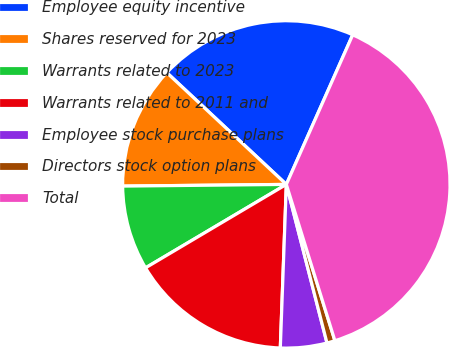Convert chart to OTSL. <chart><loc_0><loc_0><loc_500><loc_500><pie_chart><fcel>Employee equity incentive<fcel>Shares reserved for 2023<fcel>Warrants related to 2023<fcel>Warrants related to 2011 and<fcel>Employee stock purchase plans<fcel>Directors stock option plans<fcel>Total<nl><fcel>19.68%<fcel>12.13%<fcel>8.35%<fcel>15.9%<fcel>4.58%<fcel>0.8%<fcel>38.56%<nl></chart> 